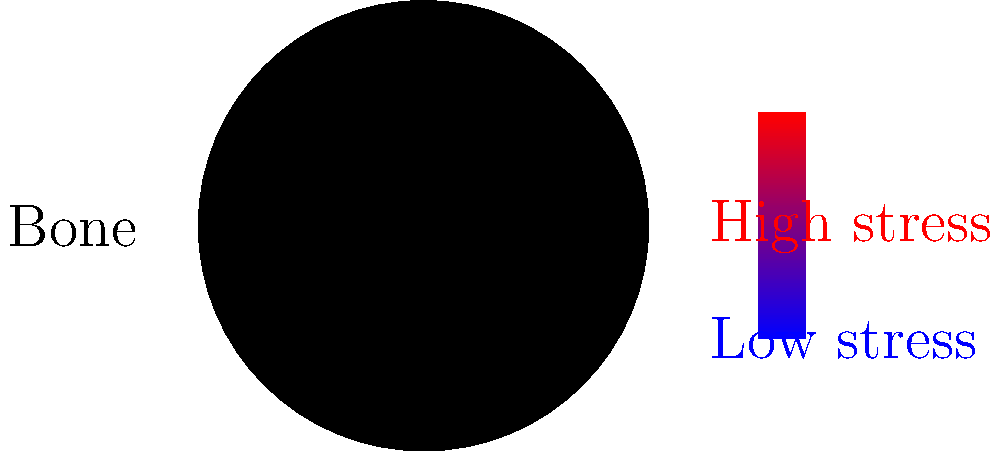In the color-coded cross-section of a nano-engineered bone implant, what does the distribution of colors suggest about the stress concentration, and how might this inform the design of future transhumanist bone augmentations? To analyze the stress distribution in the nano-engineered bone implant:

1. Observe the color gradient: Red indicates high stress, while blue indicates low stress.

2. Note the stress concentration: The highest stress (red) is concentrated near the outer edge of the implant, gradually decreasing (through orange and yellow) towards the center.

3. Consider the implications:
   a) The outer edge experiences the most stress, which could lead to potential failure points.
   b) The center of the implant experiences less stress, suggesting it may be overengineered.

4. Relate to transhumanist design principles:
   a) Biomimicry: Natural bone structures often have varying densities to optimize strength and weight.
   b) Adaptive design: Future implants could use smart materials that adapt to stress over time.

5. Potential improvements:
   a) Gradient materials: Vary the implant's composition to match the stress distribution.
   b) Nanostructures: Incorporate stress-dissipating nanostructures at high-stress areas.
   c) Self-healing mechanisms: Implement molecular-level repair systems at stress hotspots.

6. Transhumanist implications:
   a) Enhanced performance: Optimized implants could allow for superhuman strength or resilience.
   b) Longevity: Improved stress distribution could lead to longer-lasting augmentations.
   c) Customization: Stress analysis could inform personalized implant designs.

This analysis suggests that future transhumanist bone augmentations could be designed with variable-density structures, smart materials, and self-repairing capabilities to optimize performance and longevity.
Answer: Optimized variable-density structures with smart, self-repairing materials 